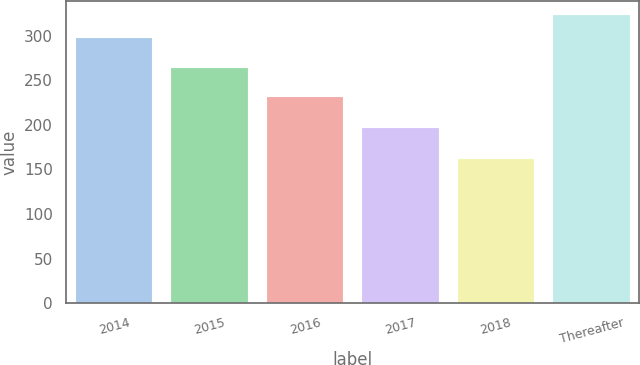Convert chart to OTSL. <chart><loc_0><loc_0><loc_500><loc_500><bar_chart><fcel>2014<fcel>2015<fcel>2016<fcel>2017<fcel>2018<fcel>Thereafter<nl><fcel>298<fcel>264<fcel>231<fcel>197<fcel>162<fcel>323<nl></chart> 